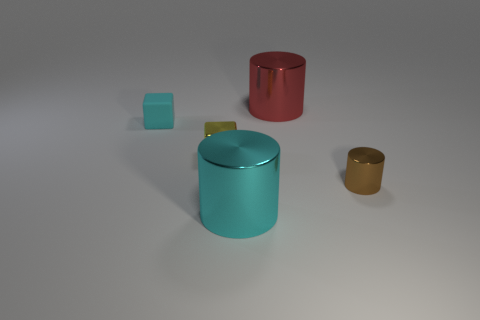There is a cylinder on the right side of the large metallic cylinder that is right of the cyan metal thing; is there a small metallic cube that is on the left side of it?
Provide a short and direct response. Yes. The thing that is the same size as the cyan cylinder is what shape?
Your answer should be compact. Cylinder. There is a metal object that is in front of the brown object; is it the same size as the cylinder behind the small yellow block?
Give a very brief answer. Yes. What number of big cylinders are there?
Offer a terse response. 2. How big is the thing that is behind the rubber cube that is left of the small metal object behind the brown thing?
Your answer should be very brief. Large. Is the color of the small metallic cube the same as the tiny cylinder?
Offer a terse response. No. Is there anything else that is the same size as the cyan metal thing?
Offer a terse response. Yes. There is a yellow shiny object; what number of large red shiny things are right of it?
Your response must be concise. 1. Is the number of tiny blocks that are right of the tiny yellow shiny thing the same as the number of big red cylinders?
Your answer should be compact. No. How many objects are either tiny yellow objects or large blue rubber things?
Make the answer very short. 1. 